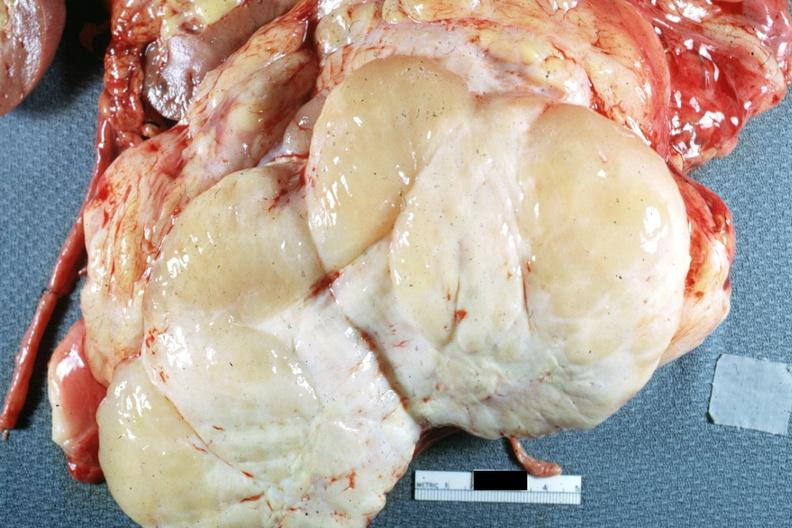where is this area in the body?
Answer the question using a single word or phrase. Abdomen 